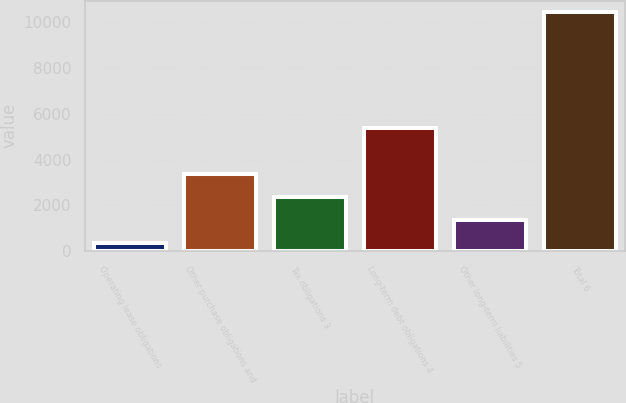Convert chart to OTSL. <chart><loc_0><loc_0><loc_500><loc_500><bar_chart><fcel>Operating lease obligations<fcel>Other purchase obligations and<fcel>Tax obligations 3<fcel>Long-term debt obligations 4<fcel>Other long-term liabilities 5<fcel>Total 6<nl><fcel>348<fcel>3373.2<fcel>2364.8<fcel>5377<fcel>1356.4<fcel>10432<nl></chart> 